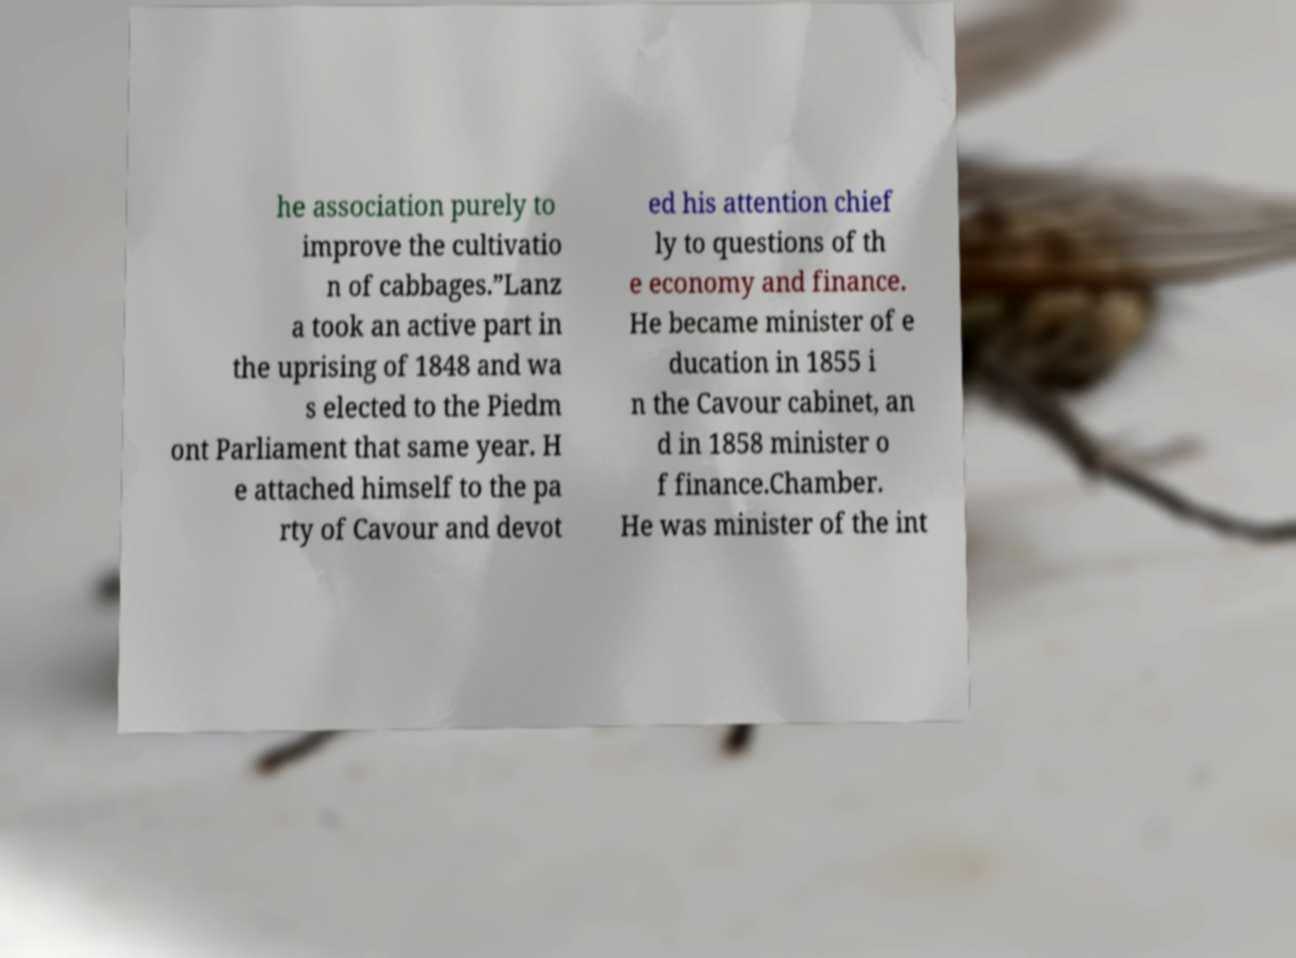Could you extract and type out the text from this image? he association purely to improve the cultivatio n of cabbages.”Lanz a took an active part in the uprising of 1848 and wa s elected to the Piedm ont Parliament that same year. H e attached himself to the pa rty of Cavour and devot ed his attention chief ly to questions of th e economy and finance. He became minister of e ducation in 1855 i n the Cavour cabinet, an d in 1858 minister o f finance.Chamber. He was minister of the int 